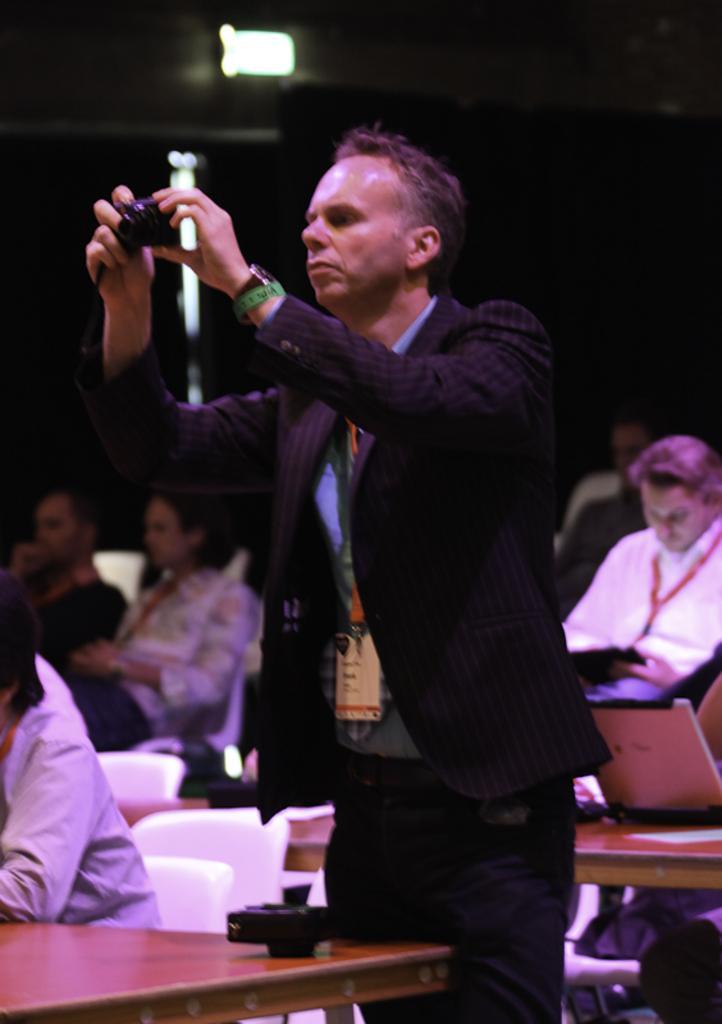Can you describe this image briefly? In the image we can see a man standing, wearing clothes, wrist watch and he is holding a camera in his hand. We can even see there are people sitting and wearing clothes. There are chairs and tables, on the table, we can see system, paper and an object. There is a light and the background is dark. 